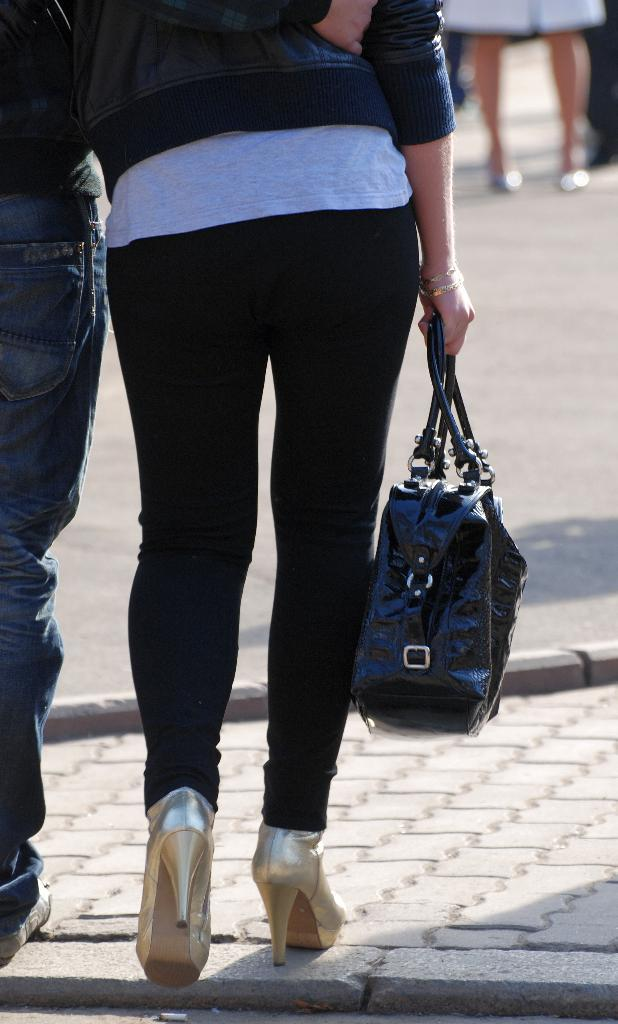How many people are present in the image? There are two people in the image. What are the people doing in the image? The people are walking on the road. Can you describe any objects that one of the people is holding? One of the people is holding a bag. Are the two people in the image sisters? There is no information in the image to suggest that the two people are sisters. 